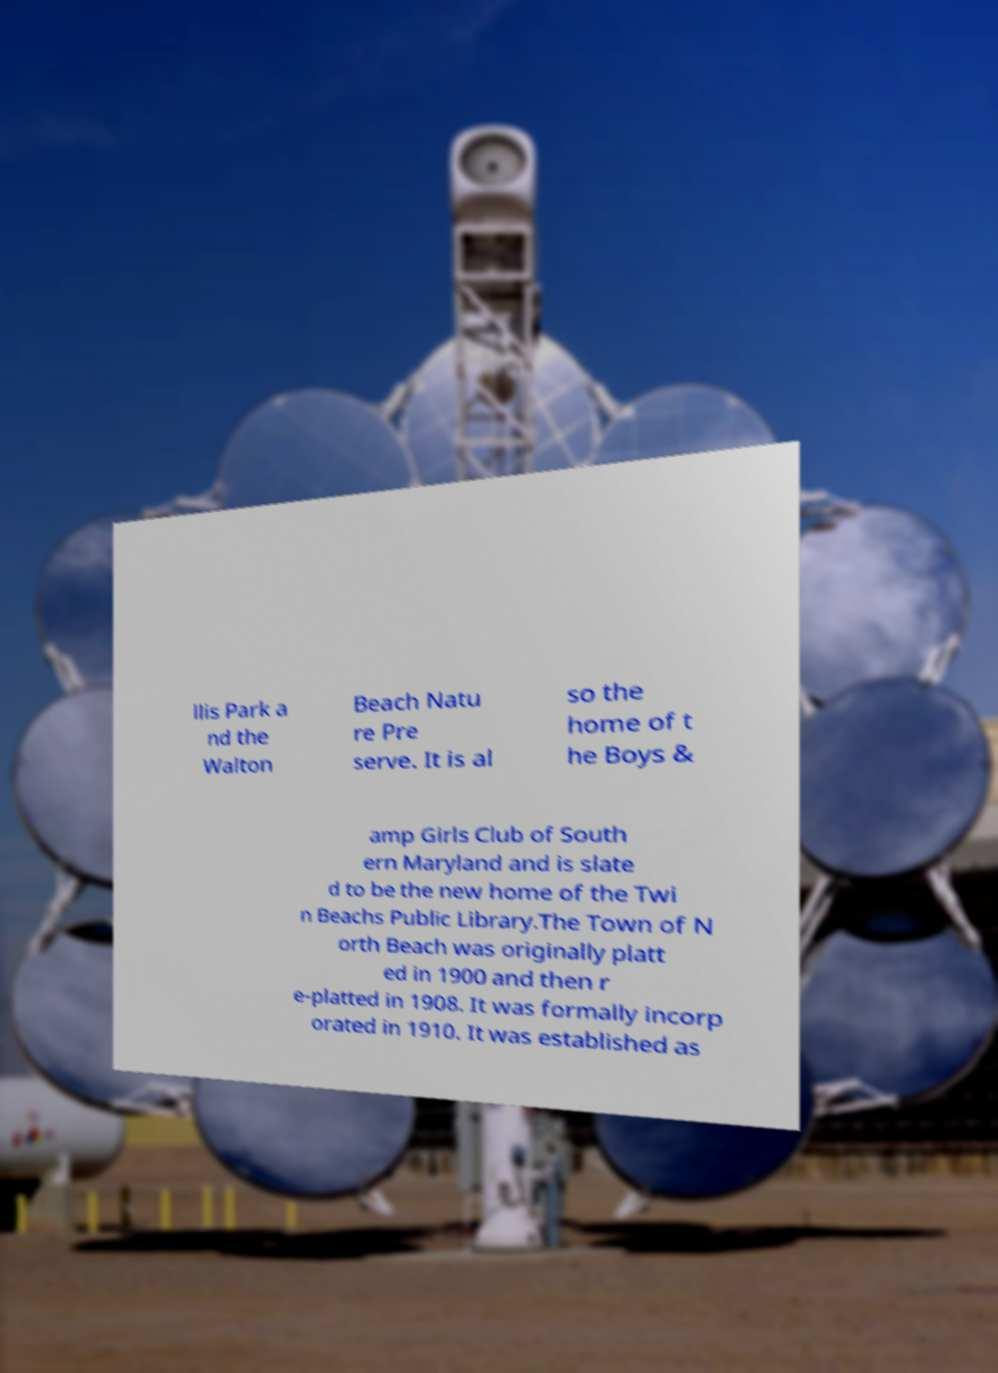I need the written content from this picture converted into text. Can you do that? llis Park a nd the Walton Beach Natu re Pre serve. It is al so the home of t he Boys & amp Girls Club of South ern Maryland and is slate d to be the new home of the Twi n Beachs Public Library.The Town of N orth Beach was originally platt ed in 1900 and then r e-platted in 1908. It was formally incorp orated in 1910. It was established as 